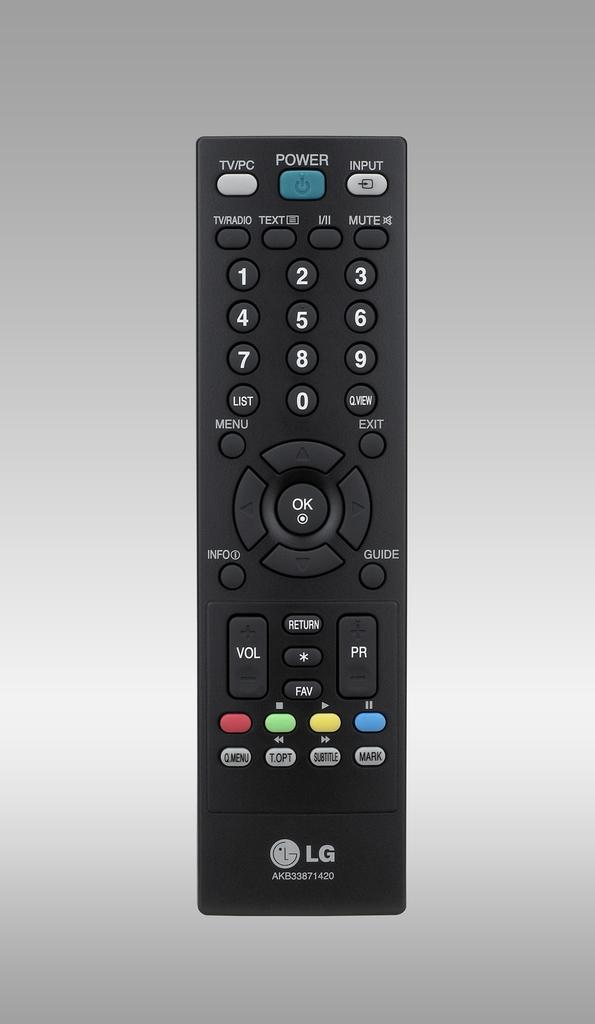Provide a one-sentence caption for the provided image. An LG remote control with a blue Power button at the top. 